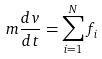<formula> <loc_0><loc_0><loc_500><loc_500>m \frac { d v } { d t } = \sum _ { i = 1 } ^ { N } f _ { i }</formula> 